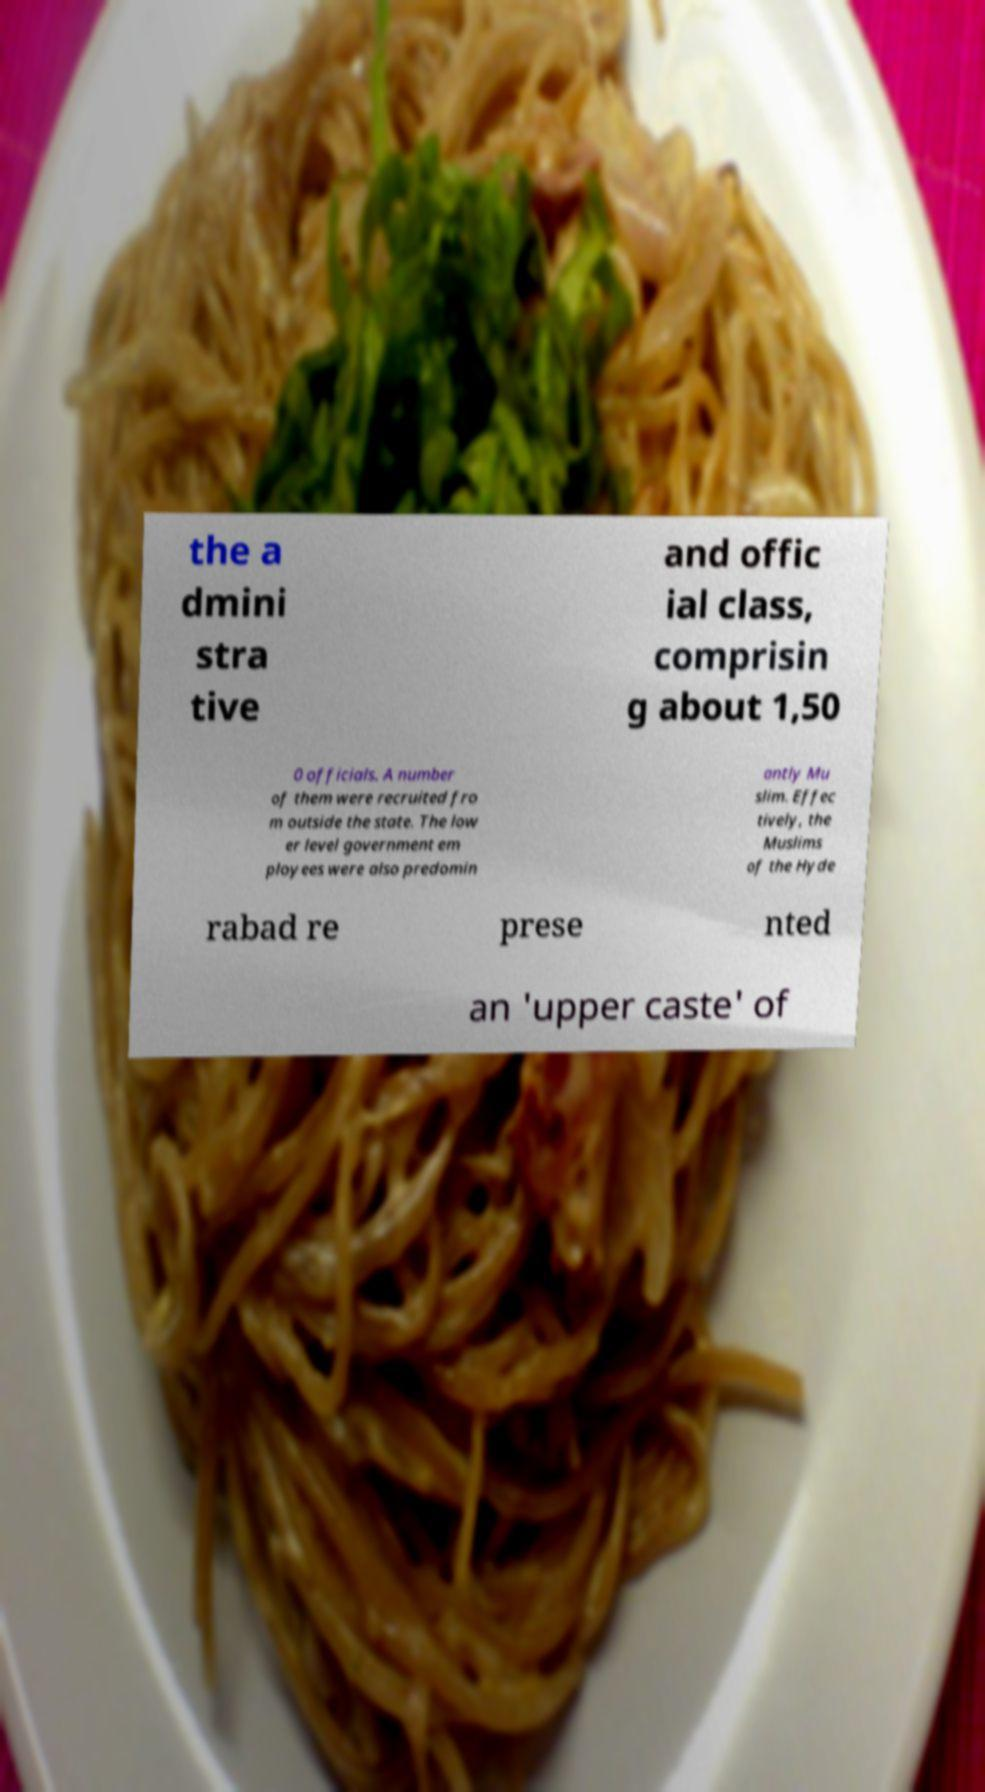Can you read and provide the text displayed in the image?This photo seems to have some interesting text. Can you extract and type it out for me? the a dmini stra tive and offic ial class, comprisin g about 1,50 0 officials. A number of them were recruited fro m outside the state. The low er level government em ployees were also predomin antly Mu slim. Effec tively, the Muslims of the Hyde rabad re prese nted an 'upper caste' of 